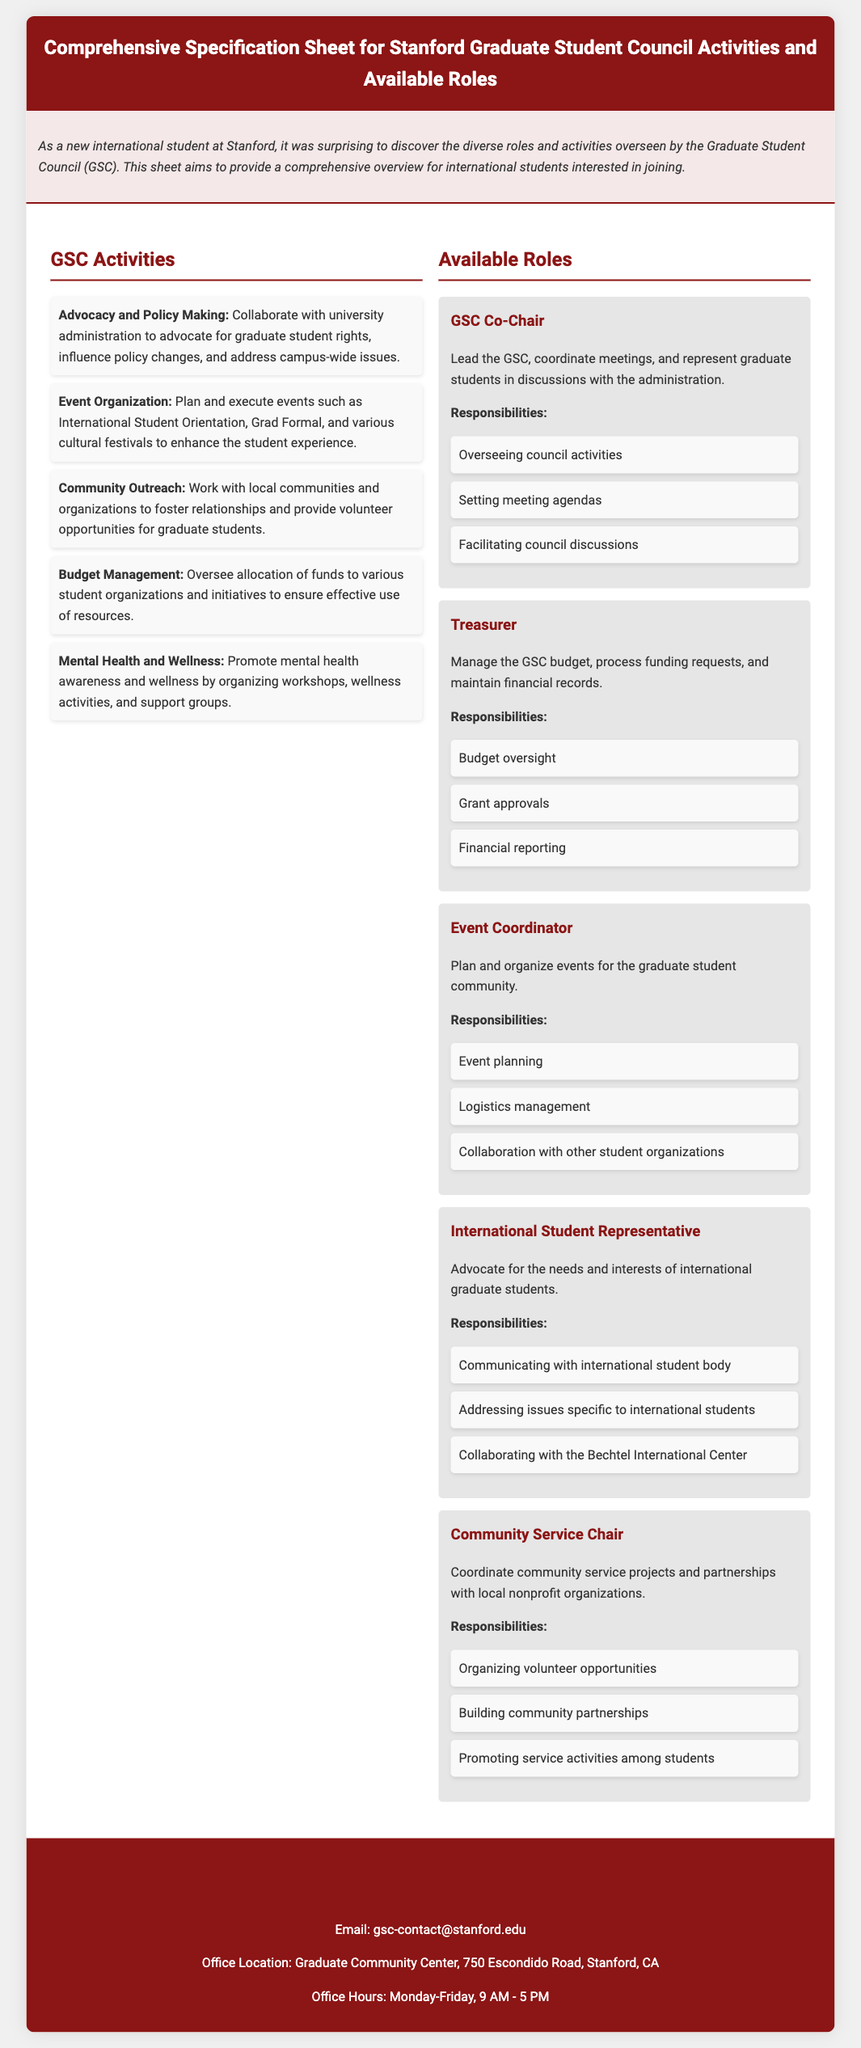what is the title of the document? The title is prominently displayed in the header of the document.
Answer: Comprehensive Specification Sheet for Stanford Graduate Student Council Activities and Available Roles how many main activities are listed under GSC Activities? The document provides a list of specific activities conducted by the GSC.
Answer: Five what role is responsible for managing the budget? The document specifies which role oversees financial matters.
Answer: Treasurer who can be contacted for more information about the GSC? The document includes contact information at the bottom section.
Answer: gsc-contact@stanford.edu what is the office location of the Graduate Student Council? The document mentions the physical location of the GSC office.
Answer: Graduate Community Center, 750 Escondido Road, Stanford, CA which role advocates for international graduate students? The document describes the roles and their responsibilities, including advocacy for a specific group.
Answer: International Student Representative what is the office hours of the GSC? The document lists the operational hours of the GSC office.
Answer: Monday-Friday, 9 AM - 5 PM name one event organized by the GSC. The activities section includes examples of events planned by the GSC.
Answer: International Student Orientation how many responsibilities are mentioned for the Event Coordinator role? The document outlines several duties associated with the Event Coordinator position.
Answer: Three 